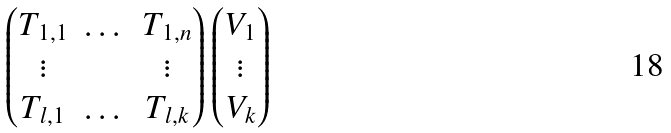<formula> <loc_0><loc_0><loc_500><loc_500>\begin{pmatrix} T _ { 1 , 1 } & \dots & T _ { 1 , n } \\ \vdots & & \vdots \\ T _ { l , 1 } & \dots & T _ { l , k } \\ \end{pmatrix} \begin{pmatrix} V _ { 1 } \\ \vdots \\ V _ { k } \end{pmatrix}</formula> 